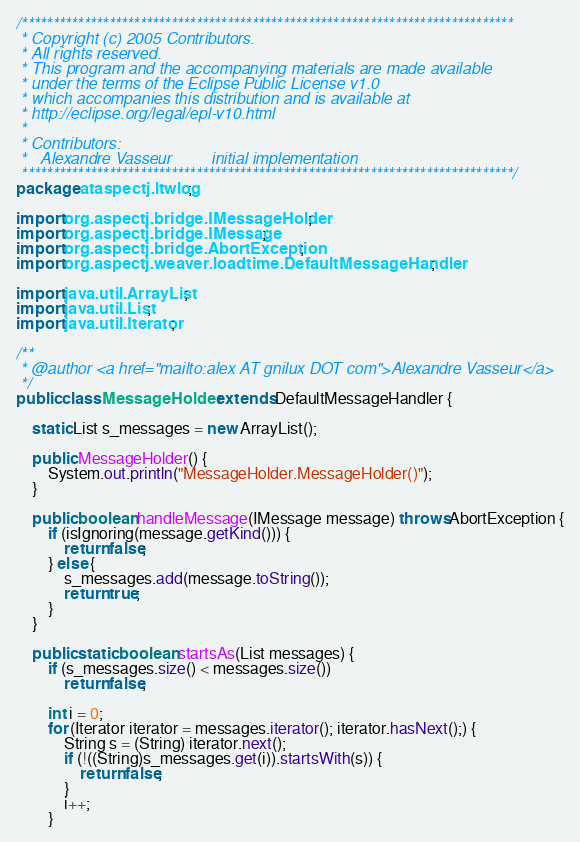<code> <loc_0><loc_0><loc_500><loc_500><_Java_>/*******************************************************************************
 * Copyright (c) 2005 Contributors.
 * All rights reserved. 
 * This program and the accompanying materials are made available 
 * under the terms of the Eclipse Public License v1.0 
 * which accompanies this distribution and is available at 
 * http://eclipse.org/legal/epl-v10.html 
 * 
 * Contributors:
 *   Alexandre Vasseur         initial implementation
 *******************************************************************************/
package ataspectj.ltwlog;

import org.aspectj.bridge.IMessageHolder;
import org.aspectj.bridge.IMessage;
import org.aspectj.bridge.AbortException;
import org.aspectj.weaver.loadtime.DefaultMessageHandler;

import java.util.ArrayList;
import java.util.List;
import java.util.Iterator;

/**
 * @author <a href="mailto:alex AT gnilux DOT com">Alexandre Vasseur</a>
 */
public class MessageHolder extends DefaultMessageHandler {

    static List s_messages = new ArrayList();

    public MessageHolder() {
    	System.out.println("MessageHolder.MessageHolder()");
    }

    public boolean handleMessage(IMessage message) throws AbortException {
        if (isIgnoring(message.getKind())) {
            return false;
        } else {
            s_messages.add(message.toString());
            return true;
        }
    }

    public static boolean startsAs(List messages) {
        if (s_messages.size() < messages.size())
            return false;

        int i = 0;
        for (Iterator iterator = messages.iterator(); iterator.hasNext();) {
            String s = (String) iterator.next();
            if (!((String)s_messages.get(i)).startsWith(s)) {
                return false;
            }
            i++;
        }</code> 